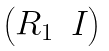<formula> <loc_0><loc_0><loc_500><loc_500>\begin{pmatrix} R _ { 1 } & I \end{pmatrix}</formula> 